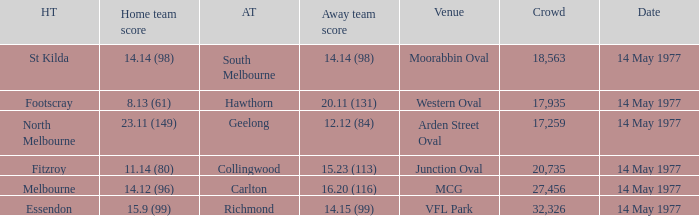Name the away team for essendon Richmond. 